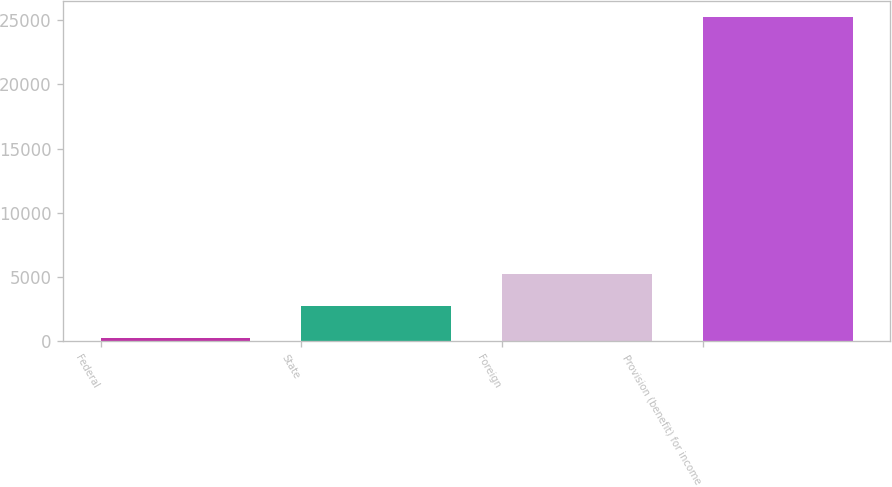<chart> <loc_0><loc_0><loc_500><loc_500><bar_chart><fcel>Federal<fcel>State<fcel>Foreign<fcel>Provision (benefit) for income<nl><fcel>251<fcel>2748.6<fcel>5246.2<fcel>25227<nl></chart> 